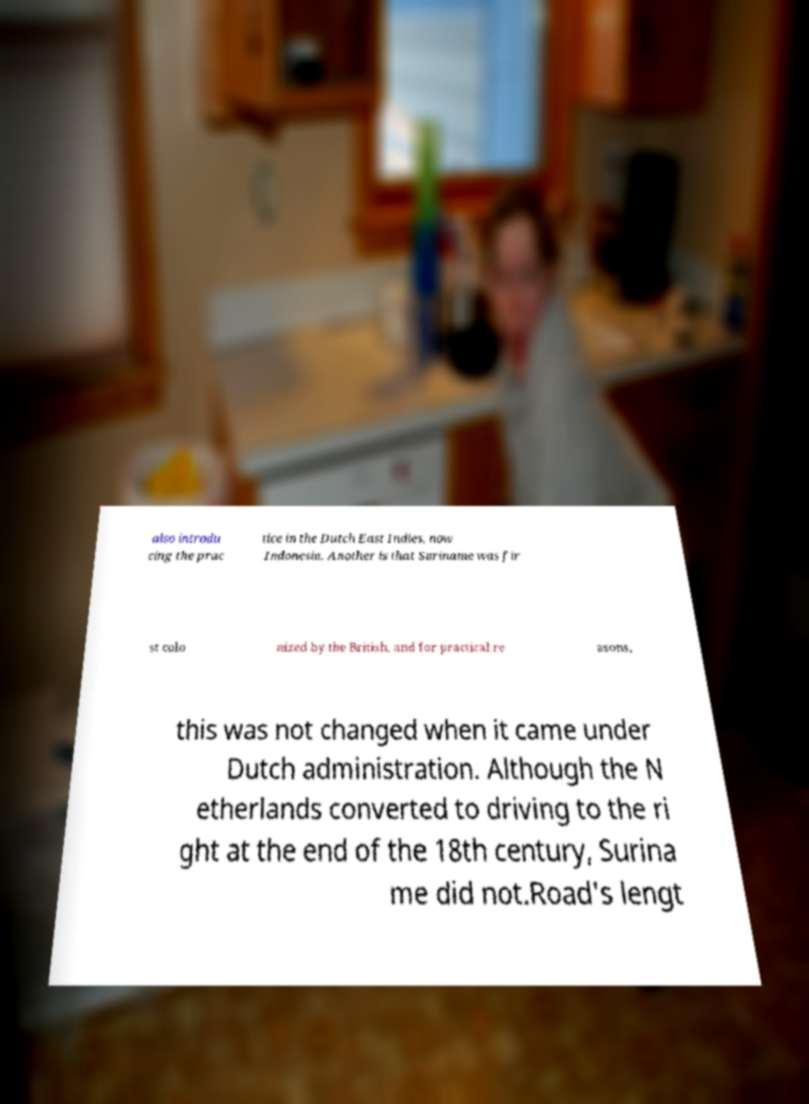Can you accurately transcribe the text from the provided image for me? also introdu cing the prac tice in the Dutch East Indies, now Indonesia. Another is that Suriname was fir st colo nized by the British, and for practical re asons, this was not changed when it came under Dutch administration. Although the N etherlands converted to driving to the ri ght at the end of the 18th century, Surina me did not.Road's lengt 